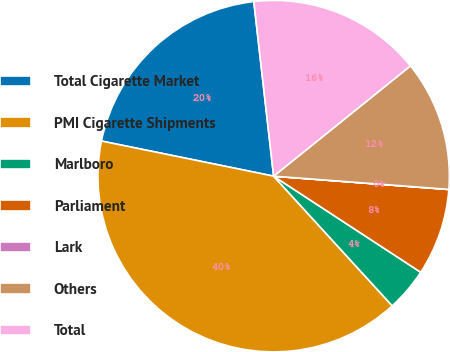<chart> <loc_0><loc_0><loc_500><loc_500><pie_chart><fcel>Total Cigarette Market<fcel>PMI Cigarette Shipments<fcel>Marlboro<fcel>Parliament<fcel>Lark<fcel>Others<fcel>Total<nl><fcel>20.0%<fcel>39.99%<fcel>4.0%<fcel>8.0%<fcel>0.01%<fcel>12.0%<fcel>16.0%<nl></chart> 